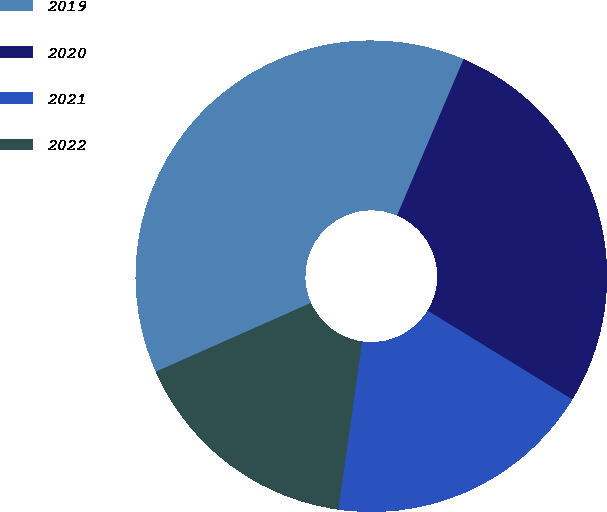Convert chart. <chart><loc_0><loc_0><loc_500><loc_500><pie_chart><fcel>2019<fcel>2020<fcel>2021<fcel>2022<nl><fcel>38.04%<fcel>27.36%<fcel>18.48%<fcel>16.12%<nl></chart> 